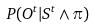Convert formula to latex. <formula><loc_0><loc_0><loc_500><loc_500>P ( O ^ { t } | S ^ { t } \wedge \pi )</formula> 